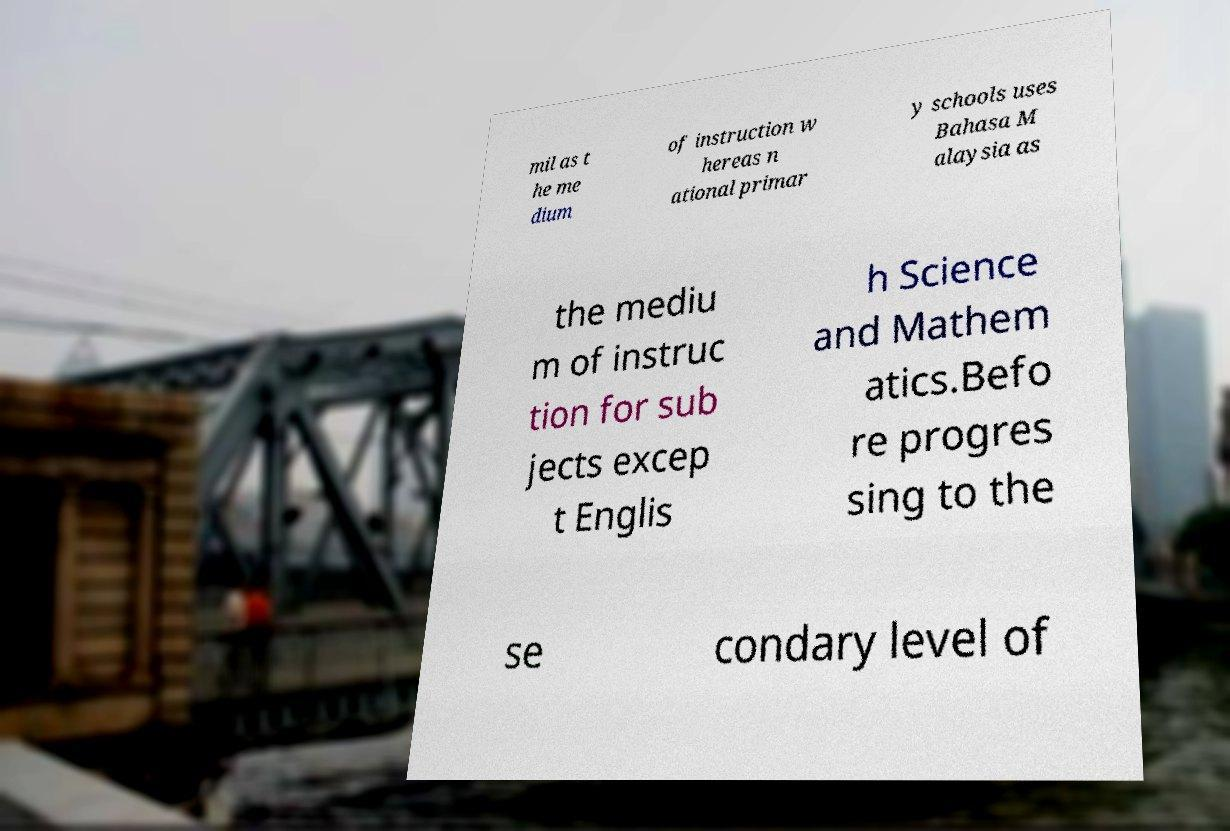Could you extract and type out the text from this image? mil as t he me dium of instruction w hereas n ational primar y schools uses Bahasa M alaysia as the mediu m of instruc tion for sub jects excep t Englis h Science and Mathem atics.Befo re progres sing to the se condary level of 